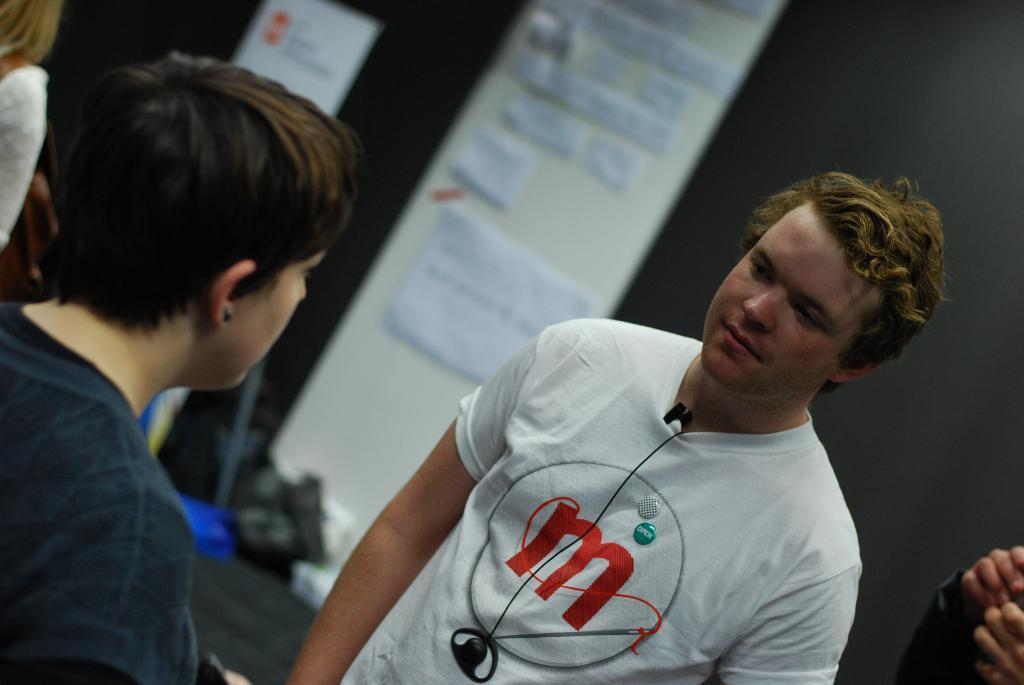Who or what can be seen in the image? There are people in the image. What is present on the ground in the image? There are many objects on the ground. What type of object has posts on it? There is an object with posts in the image. What kind of promotional material is visible in the image? There is an advertising banner in the image. What hobbies do the people in the image have? There is no information about the hobbies of the people in the image. How does the nerve affect the image? There is no mention of a nerve in the image or the provided facts. 